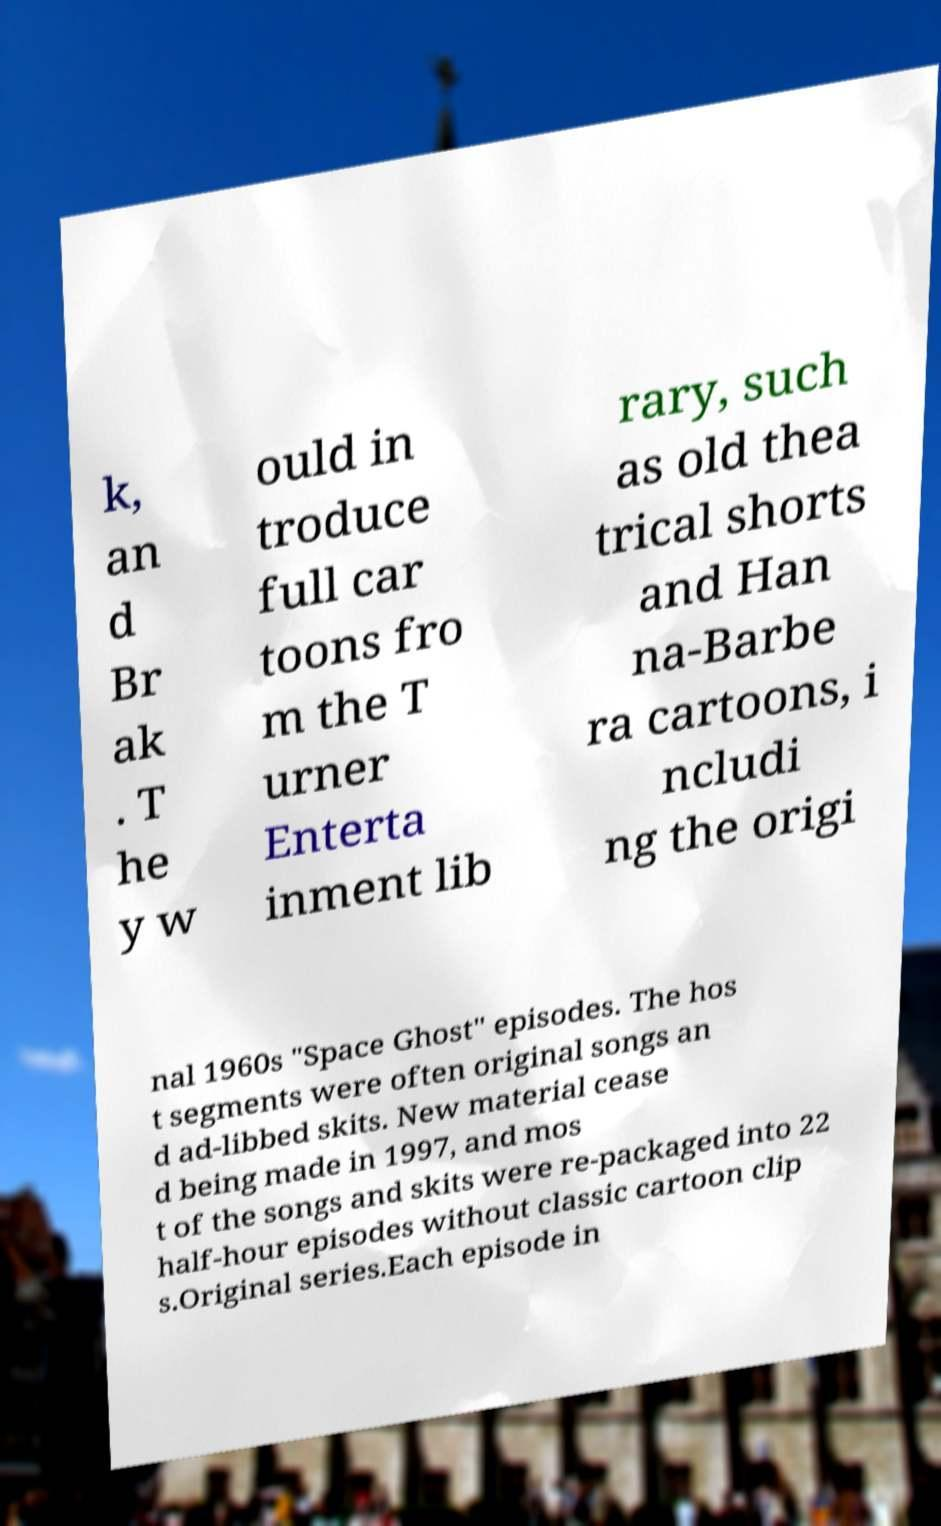Could you extract and type out the text from this image? k, an d Br ak . T he y w ould in troduce full car toons fro m the T urner Enterta inment lib rary, such as old thea trical shorts and Han na-Barbe ra cartoons, i ncludi ng the origi nal 1960s "Space Ghost" episodes. The hos t segments were often original songs an d ad-libbed skits. New material cease d being made in 1997, and mos t of the songs and skits were re-packaged into 22 half-hour episodes without classic cartoon clip s.Original series.Each episode in 